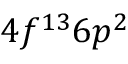<formula> <loc_0><loc_0><loc_500><loc_500>4 f ^ { 1 3 } 6 p ^ { 2 }</formula> 